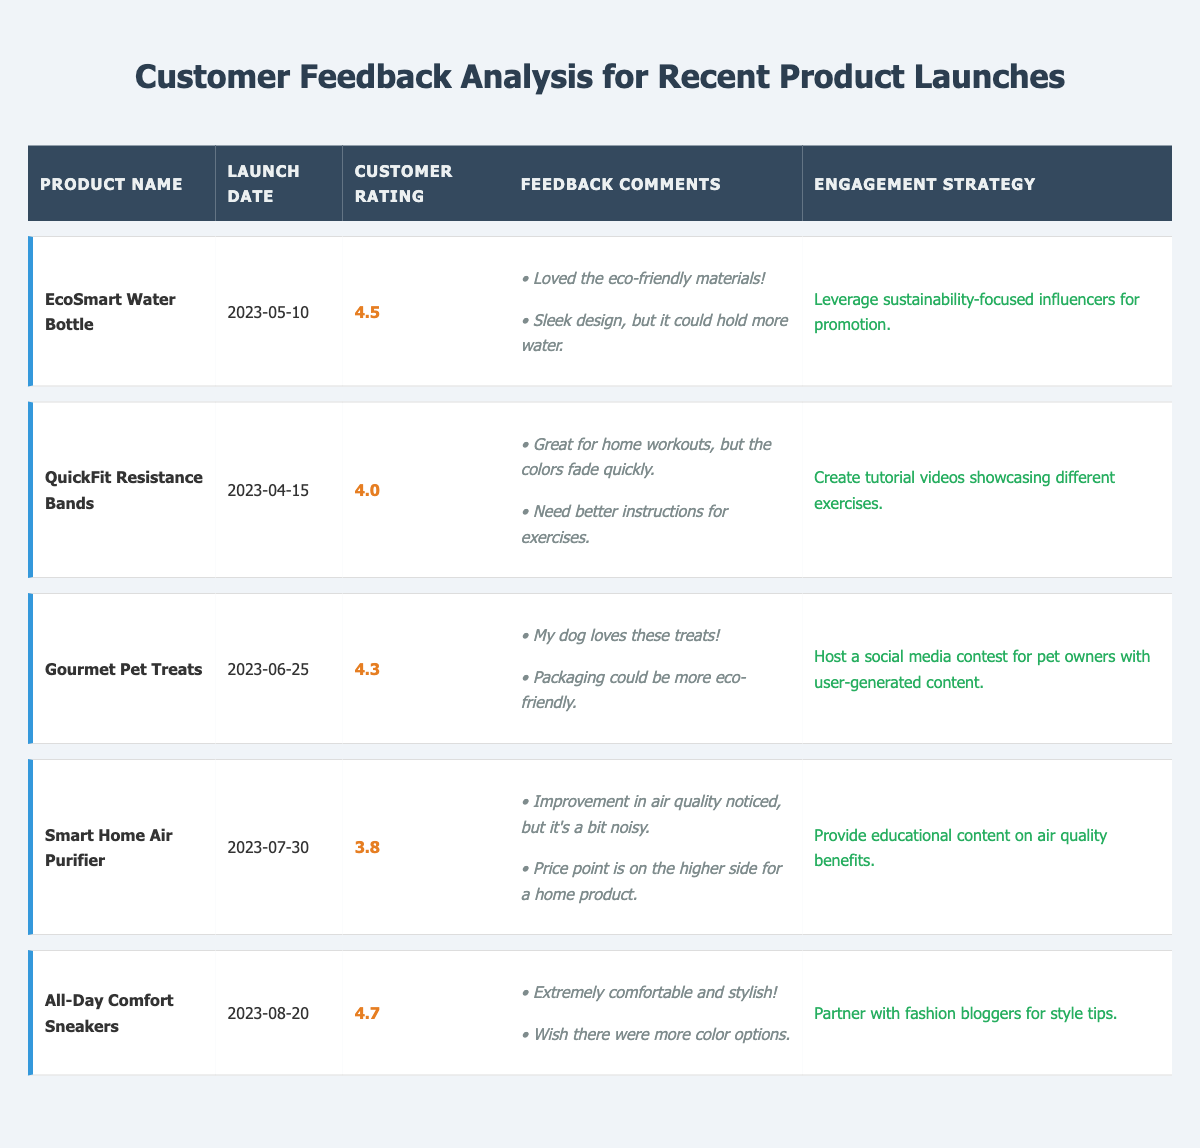What is the customer rating for the EcoSmart Water Bottle? The customer rating for the EcoSmart Water Bottle is listed in the table under the "Customer Rating" column. It shows a rating of 4.5.
Answer: 4.5 Which product has the lowest customer rating? The Smart Home Air Purifier has the lowest customer rating at 3.8, as it is the only product with a rating lower than the others listed in the table.
Answer: Smart Home Air Purifier How many products received a customer rating of 4.5 or higher? By checking the "Customer Rating" column, I see the EcoSmart Water Bottle (4.5), Gourmet Pet Treats (4.3), All-Day Comfort Sneakers (4.7), and QuickFit Resistance Bands (4.0). This accounts for three products with ratings above 4.5.
Answer: 3 What is the average customer rating for all products listed? To find the average, sum the ratings: (4.5 + 4.0 + 4.3 + 3.8 + 4.7) = 21.3. There are 5 products, so dividing by 5 gives 21.3 / 5 = 4.26.
Answer: 4.26 Did customers express concerns about the packaging of the Gourmet Pet Treats? Yes, one of the feedback comments for the Gourmet Pet Treats mentions that the packaging could be more eco-friendly, indicating a concern.
Answer: Yes What engagement strategy is suggested for the QuickFit Resistance Bands product? The engagement strategy for QuickFit Resistance Bands is to create tutorial videos showcasing different exercises, as indicated in the table under the "Engagement Strategy" column.
Answer: Create tutorial videos showcasing different exercises Which product received feedback about color options? The All-Day Comfort Sneakers received feedback wishing there were more color options, as stated in its feedback comments in the table.
Answer: All-Day Comfort Sneakers If we combine the total customer ratings for the EcoSmart Water Bottle and Gourmet Pet Treats, what is the result? The EcoSmart Water Bottle has a rating of 4.5 and the Gourmet Pet Treats has a rating of 4.3. Adding these two gives 4.5 + 4.3 = 8.8.
Answer: 8.8 